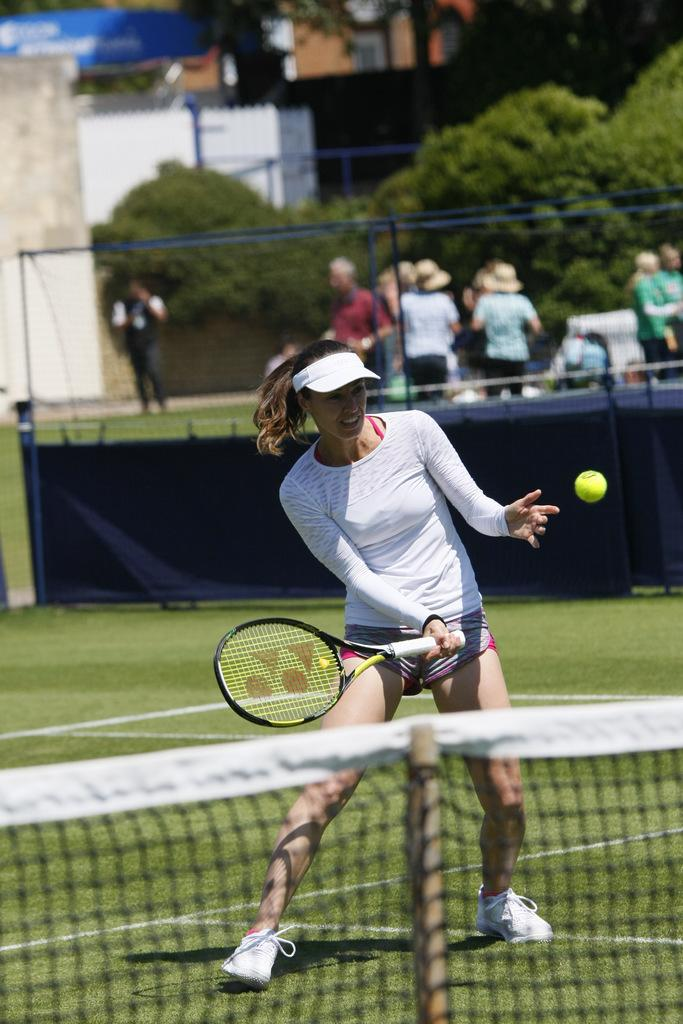Who is the main subject in the image? There is a woman in the image. What is the woman holding in her hand? The woman is holding a racket in her hand. What other object related to the sport can be seen in the image? There is a tennis ball in the image. What can be seen in the background of the image? There are people and trees in the background of the image. What type of jam is the woman spreading on the turkey in the image? There is no turkey or jam present in the image; it features a woman holding a racket and a tennis ball. Does the existence of the woman in the image prove the existence of extraterrestrial life? The presence of the woman in the image does not prove the existence of extraterrestrial life, as she appears to be a human playing tennis. 